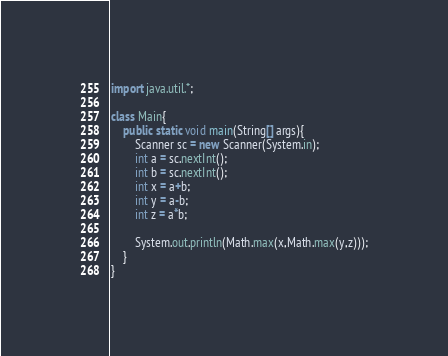Convert code to text. <code><loc_0><loc_0><loc_500><loc_500><_Java_>import java.util.*;

class Main{
    public static void main(String[] args){
        Scanner sc = new Scanner(System.in);
        int a = sc.nextInt();
        int b = sc.nextInt();
        int x = a+b;
        int y = a-b;
        int z = a*b;

        System.out.println(Math.max(x,Math.max(y,z)));
    }
}</code> 